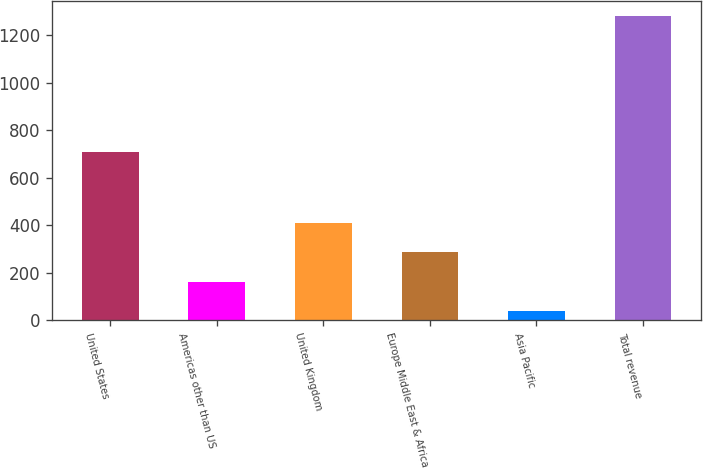Convert chart to OTSL. <chart><loc_0><loc_0><loc_500><loc_500><bar_chart><fcel>United States<fcel>Americas other than US<fcel>United Kingdom<fcel>Europe Middle East & Africa<fcel>Asia Pacific<fcel>Total revenue<nl><fcel>708<fcel>160.6<fcel>409.8<fcel>285.2<fcel>36<fcel>1282<nl></chart> 